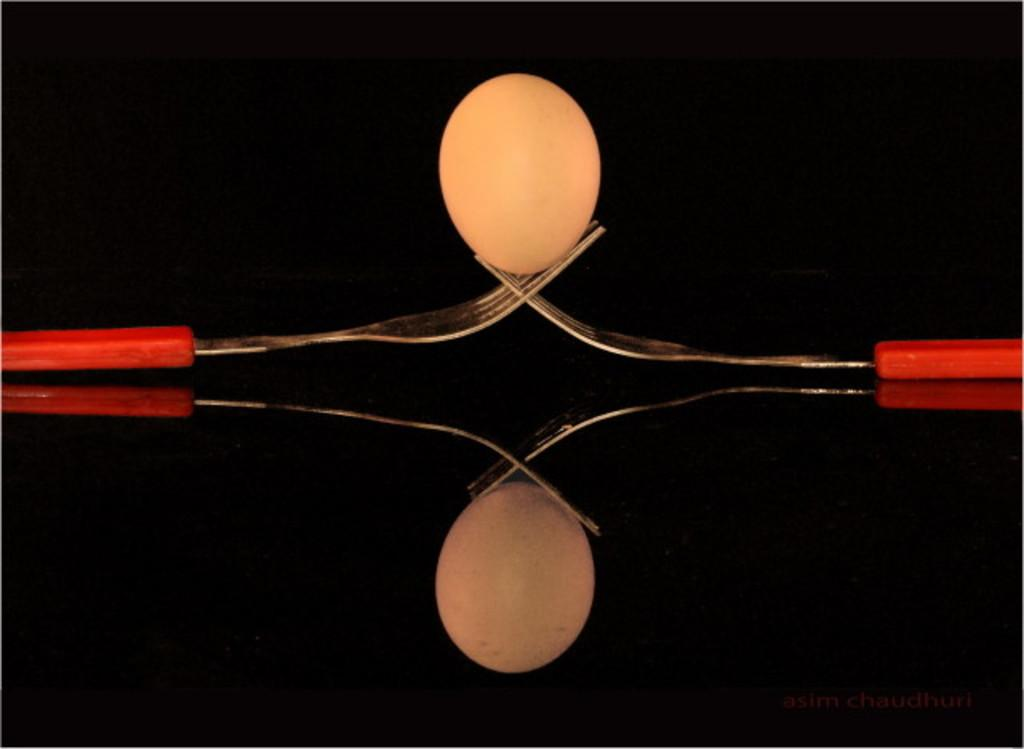How many forks are visible in the image? There are two forks in the image. What is on the forks? There is an object in white color on the forks. What can be observed about the background of the image? The background of the image is dark. What is the rate of the men walking in the image? There are no men or walking activity present in the image. 